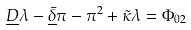<formula> <loc_0><loc_0><loc_500><loc_500>\underline { D } \lambda - \underline { \bar { \delta } } \pi - \pi ^ { 2 } + \tilde { \kappa } \lambda = \Phi _ { 0 2 }</formula> 